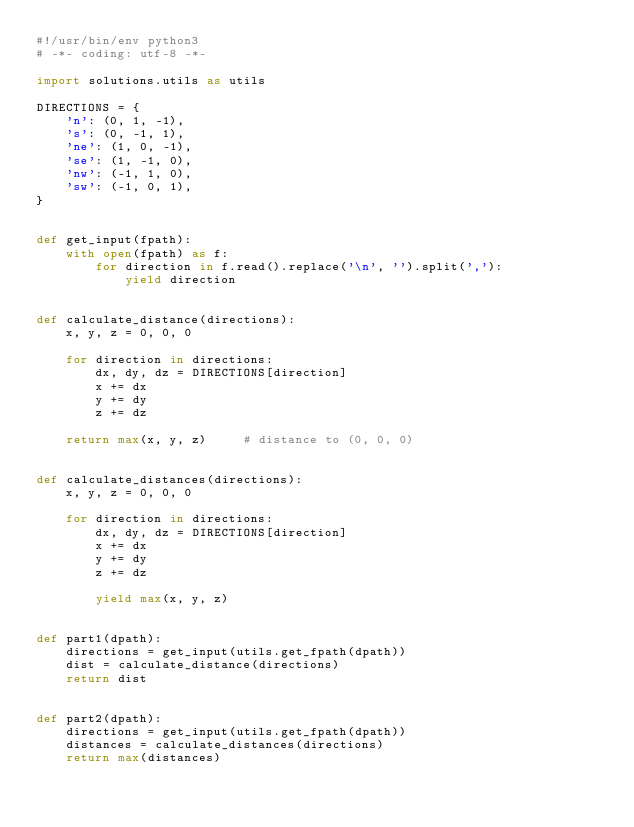Convert code to text. <code><loc_0><loc_0><loc_500><loc_500><_Python_>#!/usr/bin/env python3
# -*- coding: utf-8 -*-

import solutions.utils as utils

DIRECTIONS = {
    'n': (0, 1, -1),
    's': (0, -1, 1),
    'ne': (1, 0, -1),
    'se': (1, -1, 0),
    'nw': (-1, 1, 0),
    'sw': (-1, 0, 1),
}


def get_input(fpath):
    with open(fpath) as f:
        for direction in f.read().replace('\n', '').split(','):
            yield direction


def calculate_distance(directions):
    x, y, z = 0, 0, 0

    for direction in directions:
        dx, dy, dz = DIRECTIONS[direction]
        x += dx
        y += dy
        z += dz

    return max(x, y, z)     # distance to (0, 0, 0)


def calculate_distances(directions):
    x, y, z = 0, 0, 0

    for direction in directions:
        dx, dy, dz = DIRECTIONS[direction]
        x += dx
        y += dy
        z += dz

        yield max(x, y, z)


def part1(dpath):
    directions = get_input(utils.get_fpath(dpath))
    dist = calculate_distance(directions)
    return dist


def part2(dpath):
    directions = get_input(utils.get_fpath(dpath))
    distances = calculate_distances(directions)
    return max(distances)
</code> 